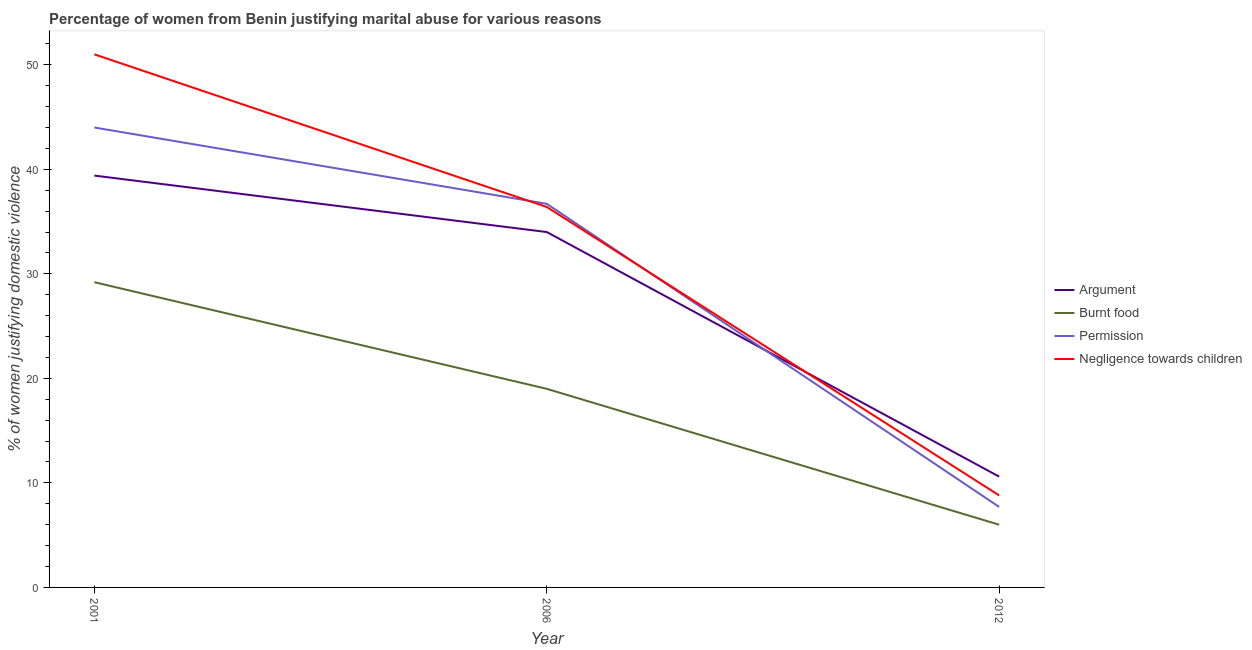Does the line corresponding to percentage of women justifying abuse in the case of an argument intersect with the line corresponding to percentage of women justifying abuse for going without permission?
Offer a terse response. Yes. What is the percentage of women justifying abuse for showing negligence towards children in 2012?
Your answer should be compact. 8.8. Across all years, what is the minimum percentage of women justifying abuse for showing negligence towards children?
Your answer should be very brief. 8.8. What is the difference between the percentage of women justifying abuse in the case of an argument in 2001 and that in 2012?
Ensure brevity in your answer.  28.8. What is the difference between the percentage of women justifying abuse for going without permission in 2001 and the percentage of women justifying abuse for burning food in 2006?
Your response must be concise. 25. What is the average percentage of women justifying abuse for showing negligence towards children per year?
Offer a terse response. 32.07. In the year 2006, what is the difference between the percentage of women justifying abuse for burning food and percentage of women justifying abuse for showing negligence towards children?
Offer a terse response. -17.4. What is the ratio of the percentage of women justifying abuse for showing negligence towards children in 2001 to that in 2006?
Your answer should be very brief. 1.4. What is the difference between the highest and the second highest percentage of women justifying abuse for burning food?
Your answer should be compact. 10.2. What is the difference between the highest and the lowest percentage of women justifying abuse for burning food?
Offer a terse response. 23.2. Is the sum of the percentage of women justifying abuse for showing negligence towards children in 2006 and 2012 greater than the maximum percentage of women justifying abuse for going without permission across all years?
Your response must be concise. Yes. Is it the case that in every year, the sum of the percentage of women justifying abuse for showing negligence towards children and percentage of women justifying abuse for going without permission is greater than the sum of percentage of women justifying abuse for burning food and percentage of women justifying abuse in the case of an argument?
Provide a succinct answer. No. Does the percentage of women justifying abuse for showing negligence towards children monotonically increase over the years?
Your response must be concise. No. Is the percentage of women justifying abuse for showing negligence towards children strictly greater than the percentage of women justifying abuse in the case of an argument over the years?
Keep it short and to the point. No. How many lines are there?
Your response must be concise. 4. How many years are there in the graph?
Provide a short and direct response. 3. What is the difference between two consecutive major ticks on the Y-axis?
Provide a succinct answer. 10. Are the values on the major ticks of Y-axis written in scientific E-notation?
Give a very brief answer. No. Does the graph contain any zero values?
Your answer should be compact. No. Does the graph contain grids?
Your answer should be very brief. No. Where does the legend appear in the graph?
Offer a terse response. Center right. How many legend labels are there?
Keep it short and to the point. 4. What is the title of the graph?
Your answer should be compact. Percentage of women from Benin justifying marital abuse for various reasons. What is the label or title of the Y-axis?
Provide a succinct answer. % of women justifying domestic violence. What is the % of women justifying domestic violence of Argument in 2001?
Offer a very short reply. 39.4. What is the % of women justifying domestic violence of Burnt food in 2001?
Your answer should be very brief. 29.2. What is the % of women justifying domestic violence of Argument in 2006?
Keep it short and to the point. 34. What is the % of women justifying domestic violence of Burnt food in 2006?
Your answer should be compact. 19. What is the % of women justifying domestic violence in Permission in 2006?
Your answer should be compact. 36.7. What is the % of women justifying domestic violence in Negligence towards children in 2006?
Ensure brevity in your answer.  36.4. What is the % of women justifying domestic violence in Argument in 2012?
Keep it short and to the point. 10.6. What is the % of women justifying domestic violence in Negligence towards children in 2012?
Make the answer very short. 8.8. Across all years, what is the maximum % of women justifying domestic violence of Argument?
Ensure brevity in your answer.  39.4. Across all years, what is the maximum % of women justifying domestic violence in Burnt food?
Your answer should be very brief. 29.2. Across all years, what is the maximum % of women justifying domestic violence of Permission?
Offer a very short reply. 44. Across all years, what is the maximum % of women justifying domestic violence in Negligence towards children?
Give a very brief answer. 51. Across all years, what is the minimum % of women justifying domestic violence of Argument?
Your answer should be very brief. 10.6. What is the total % of women justifying domestic violence of Burnt food in the graph?
Offer a very short reply. 54.2. What is the total % of women justifying domestic violence of Permission in the graph?
Keep it short and to the point. 88.4. What is the total % of women justifying domestic violence in Negligence towards children in the graph?
Your answer should be compact. 96.2. What is the difference between the % of women justifying domestic violence in Argument in 2001 and that in 2006?
Offer a terse response. 5.4. What is the difference between the % of women justifying domestic violence in Permission in 2001 and that in 2006?
Make the answer very short. 7.3. What is the difference between the % of women justifying domestic violence of Negligence towards children in 2001 and that in 2006?
Provide a succinct answer. 14.6. What is the difference between the % of women justifying domestic violence in Argument in 2001 and that in 2012?
Ensure brevity in your answer.  28.8. What is the difference between the % of women justifying domestic violence in Burnt food in 2001 and that in 2012?
Your answer should be very brief. 23.2. What is the difference between the % of women justifying domestic violence of Permission in 2001 and that in 2012?
Your response must be concise. 36.3. What is the difference between the % of women justifying domestic violence of Negligence towards children in 2001 and that in 2012?
Give a very brief answer. 42.2. What is the difference between the % of women justifying domestic violence of Argument in 2006 and that in 2012?
Your answer should be very brief. 23.4. What is the difference between the % of women justifying domestic violence of Negligence towards children in 2006 and that in 2012?
Your answer should be very brief. 27.6. What is the difference between the % of women justifying domestic violence of Argument in 2001 and the % of women justifying domestic violence of Burnt food in 2006?
Your answer should be compact. 20.4. What is the difference between the % of women justifying domestic violence in Argument in 2001 and the % of women justifying domestic violence in Permission in 2006?
Keep it short and to the point. 2.7. What is the difference between the % of women justifying domestic violence of Burnt food in 2001 and the % of women justifying domestic violence of Negligence towards children in 2006?
Your response must be concise. -7.2. What is the difference between the % of women justifying domestic violence in Argument in 2001 and the % of women justifying domestic violence in Burnt food in 2012?
Give a very brief answer. 33.4. What is the difference between the % of women justifying domestic violence of Argument in 2001 and the % of women justifying domestic violence of Permission in 2012?
Ensure brevity in your answer.  31.7. What is the difference between the % of women justifying domestic violence of Argument in 2001 and the % of women justifying domestic violence of Negligence towards children in 2012?
Your answer should be very brief. 30.6. What is the difference between the % of women justifying domestic violence in Burnt food in 2001 and the % of women justifying domestic violence in Permission in 2012?
Provide a succinct answer. 21.5. What is the difference between the % of women justifying domestic violence of Burnt food in 2001 and the % of women justifying domestic violence of Negligence towards children in 2012?
Provide a succinct answer. 20.4. What is the difference between the % of women justifying domestic violence in Permission in 2001 and the % of women justifying domestic violence in Negligence towards children in 2012?
Provide a short and direct response. 35.2. What is the difference between the % of women justifying domestic violence of Argument in 2006 and the % of women justifying domestic violence of Permission in 2012?
Provide a succinct answer. 26.3. What is the difference between the % of women justifying domestic violence of Argument in 2006 and the % of women justifying domestic violence of Negligence towards children in 2012?
Your answer should be very brief. 25.2. What is the difference between the % of women justifying domestic violence of Burnt food in 2006 and the % of women justifying domestic violence of Permission in 2012?
Your response must be concise. 11.3. What is the difference between the % of women justifying domestic violence of Permission in 2006 and the % of women justifying domestic violence of Negligence towards children in 2012?
Offer a very short reply. 27.9. What is the average % of women justifying domestic violence of Argument per year?
Keep it short and to the point. 28. What is the average % of women justifying domestic violence in Burnt food per year?
Ensure brevity in your answer.  18.07. What is the average % of women justifying domestic violence in Permission per year?
Keep it short and to the point. 29.47. What is the average % of women justifying domestic violence in Negligence towards children per year?
Offer a very short reply. 32.07. In the year 2001, what is the difference between the % of women justifying domestic violence of Argument and % of women justifying domestic violence of Permission?
Your answer should be compact. -4.6. In the year 2001, what is the difference between the % of women justifying domestic violence in Burnt food and % of women justifying domestic violence in Permission?
Provide a short and direct response. -14.8. In the year 2001, what is the difference between the % of women justifying domestic violence of Burnt food and % of women justifying domestic violence of Negligence towards children?
Give a very brief answer. -21.8. In the year 2006, what is the difference between the % of women justifying domestic violence of Argument and % of women justifying domestic violence of Burnt food?
Keep it short and to the point. 15. In the year 2006, what is the difference between the % of women justifying domestic violence of Argument and % of women justifying domestic violence of Permission?
Provide a short and direct response. -2.7. In the year 2006, what is the difference between the % of women justifying domestic violence in Burnt food and % of women justifying domestic violence in Permission?
Offer a terse response. -17.7. In the year 2006, what is the difference between the % of women justifying domestic violence of Burnt food and % of women justifying domestic violence of Negligence towards children?
Your answer should be compact. -17.4. In the year 2012, what is the difference between the % of women justifying domestic violence of Argument and % of women justifying domestic violence of Permission?
Your answer should be compact. 2.9. What is the ratio of the % of women justifying domestic violence of Argument in 2001 to that in 2006?
Keep it short and to the point. 1.16. What is the ratio of the % of women justifying domestic violence of Burnt food in 2001 to that in 2006?
Offer a terse response. 1.54. What is the ratio of the % of women justifying domestic violence of Permission in 2001 to that in 2006?
Provide a succinct answer. 1.2. What is the ratio of the % of women justifying domestic violence of Negligence towards children in 2001 to that in 2006?
Keep it short and to the point. 1.4. What is the ratio of the % of women justifying domestic violence in Argument in 2001 to that in 2012?
Your answer should be compact. 3.72. What is the ratio of the % of women justifying domestic violence in Burnt food in 2001 to that in 2012?
Your response must be concise. 4.87. What is the ratio of the % of women justifying domestic violence in Permission in 2001 to that in 2012?
Give a very brief answer. 5.71. What is the ratio of the % of women justifying domestic violence of Negligence towards children in 2001 to that in 2012?
Ensure brevity in your answer.  5.8. What is the ratio of the % of women justifying domestic violence of Argument in 2006 to that in 2012?
Keep it short and to the point. 3.21. What is the ratio of the % of women justifying domestic violence of Burnt food in 2006 to that in 2012?
Your response must be concise. 3.17. What is the ratio of the % of women justifying domestic violence of Permission in 2006 to that in 2012?
Your answer should be compact. 4.77. What is the ratio of the % of women justifying domestic violence in Negligence towards children in 2006 to that in 2012?
Offer a very short reply. 4.14. What is the difference between the highest and the second highest % of women justifying domestic violence in Argument?
Offer a very short reply. 5.4. What is the difference between the highest and the second highest % of women justifying domestic violence of Negligence towards children?
Give a very brief answer. 14.6. What is the difference between the highest and the lowest % of women justifying domestic violence in Argument?
Provide a short and direct response. 28.8. What is the difference between the highest and the lowest % of women justifying domestic violence of Burnt food?
Offer a terse response. 23.2. What is the difference between the highest and the lowest % of women justifying domestic violence of Permission?
Give a very brief answer. 36.3. What is the difference between the highest and the lowest % of women justifying domestic violence of Negligence towards children?
Provide a succinct answer. 42.2. 